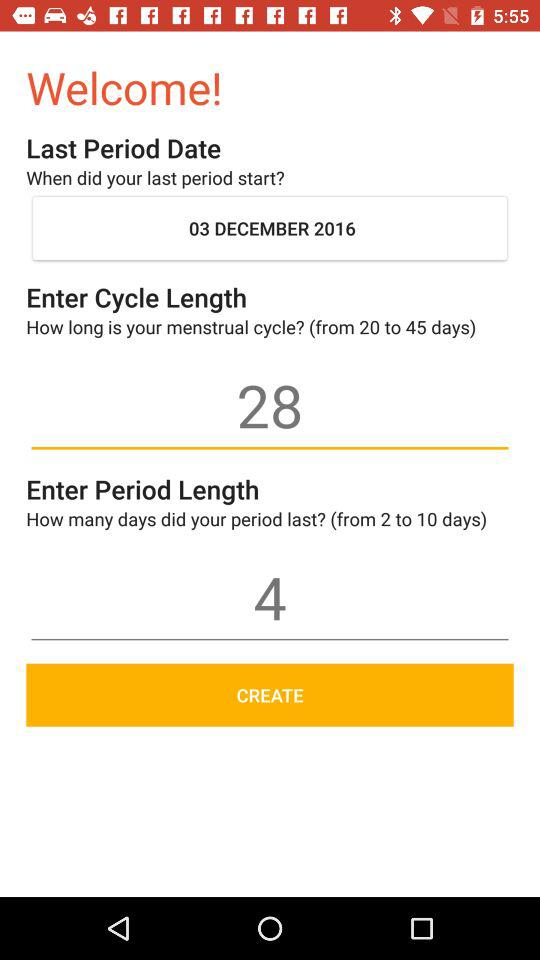What's the date of the last period? The date is December 3, 2016. 